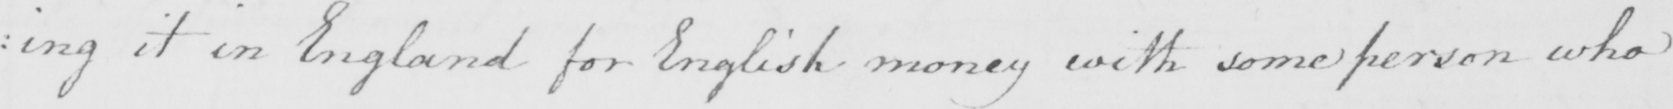Can you read and transcribe this handwriting? : ing it in England for English money with some person who 